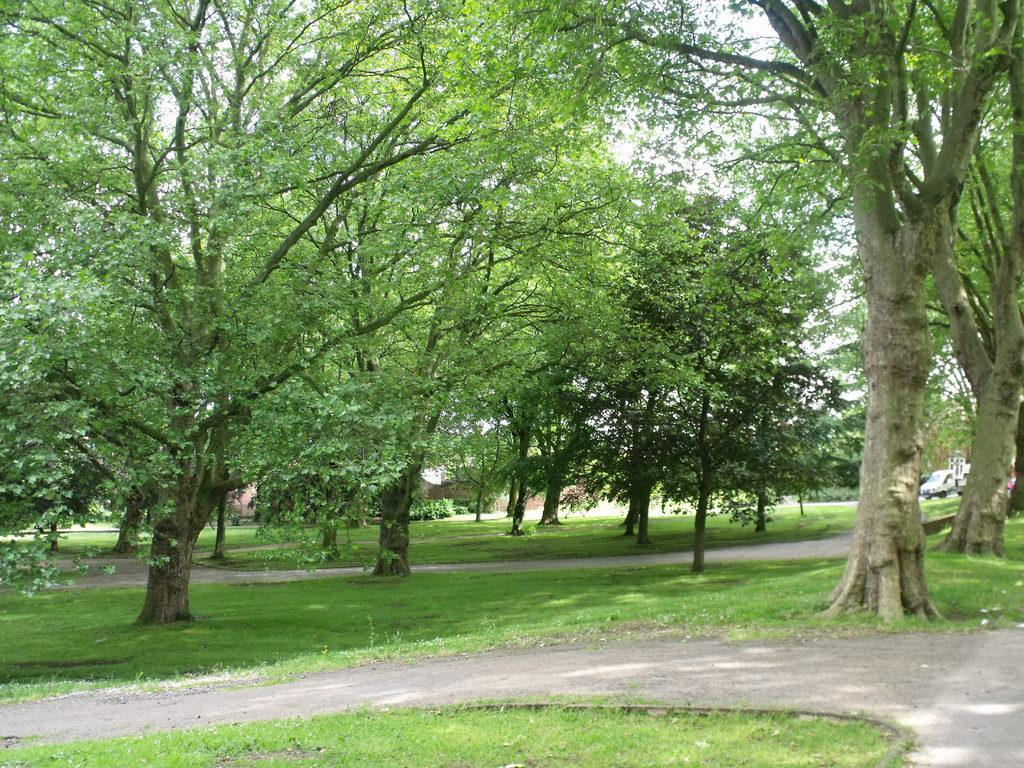What type of surface is on the ground in the image? There is grass on the ground in the image. What else can be seen on the ground in the image? There is a road in the image. What type of natural elements are present in the image? There are many trees in the image. What type of man-made object is present in the image? There is a vehicle in the image. What type of adjustment can be seen on the list in the image? There is no list present in the image, so no adjustments can be observed. 